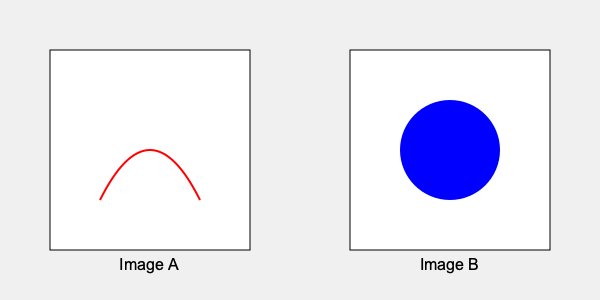As an expert in AI and art, which of the two images presented above is more likely to be AI-generated, and what characteristics lead you to this conclusion? To determine which image is more likely to be AI-generated, we need to analyze the characteristics of both images:

1. Image A:
   - Contains a smooth, continuous curve (red line)
   - The curve appears to be hand-drawn or organic in nature
   - Shows variation in line thickness and slight imperfections

2. Image B:
   - Features a perfect circle (blue)
   - The circle has a uniform fill color and sharp edges
   - Demonstrates geometric precision

3. AI-generated art characteristics:
   - Tends to excel at producing mathematically precise shapes and patterns
   - Often struggles with creating natural, organic-looking lines and curves
   - Typically generates images with consistent color application and sharp edges

4. Human-created art characteristics:
   - Often includes imperfections and variations in line quality
   - Tends to have more organic, flowing shapes
   - May show inconsistencies in color application or edge sharpness

5. Conclusion:
   Based on these observations, Image B is more likely to be AI-generated due to its perfect geometric shape and uniform color application. Image A's organic curve suggests it is more likely to be human-created.
Answer: Image B (perfect circle) is more likely AI-generated due to its geometric precision and uniformity. 